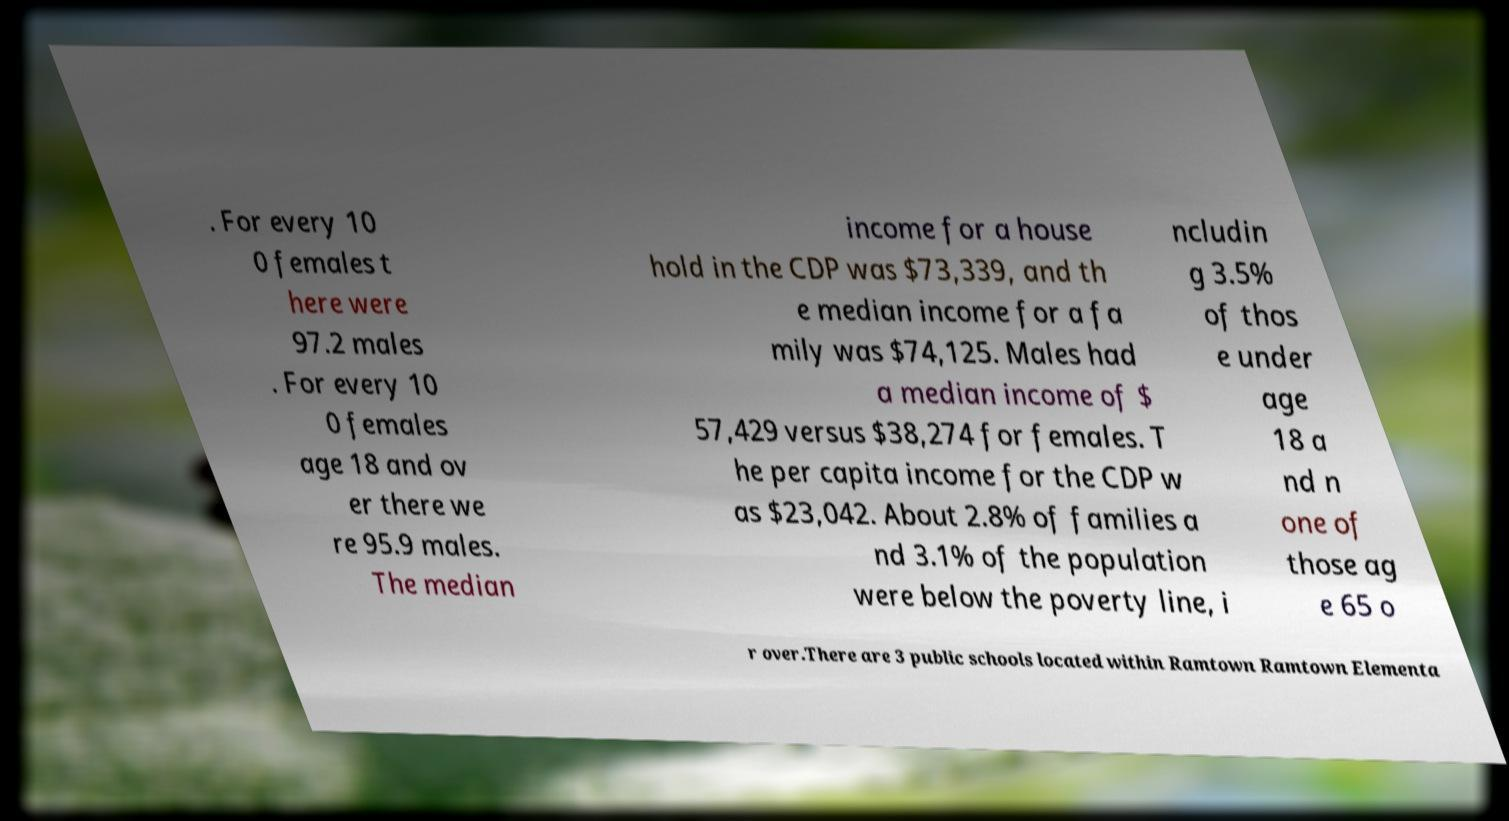Please identify and transcribe the text found in this image. . For every 10 0 females t here were 97.2 males . For every 10 0 females age 18 and ov er there we re 95.9 males. The median income for a house hold in the CDP was $73,339, and th e median income for a fa mily was $74,125. Males had a median income of $ 57,429 versus $38,274 for females. T he per capita income for the CDP w as $23,042. About 2.8% of families a nd 3.1% of the population were below the poverty line, i ncludin g 3.5% of thos e under age 18 a nd n one of those ag e 65 o r over.There are 3 public schools located within Ramtown Ramtown Elementa 